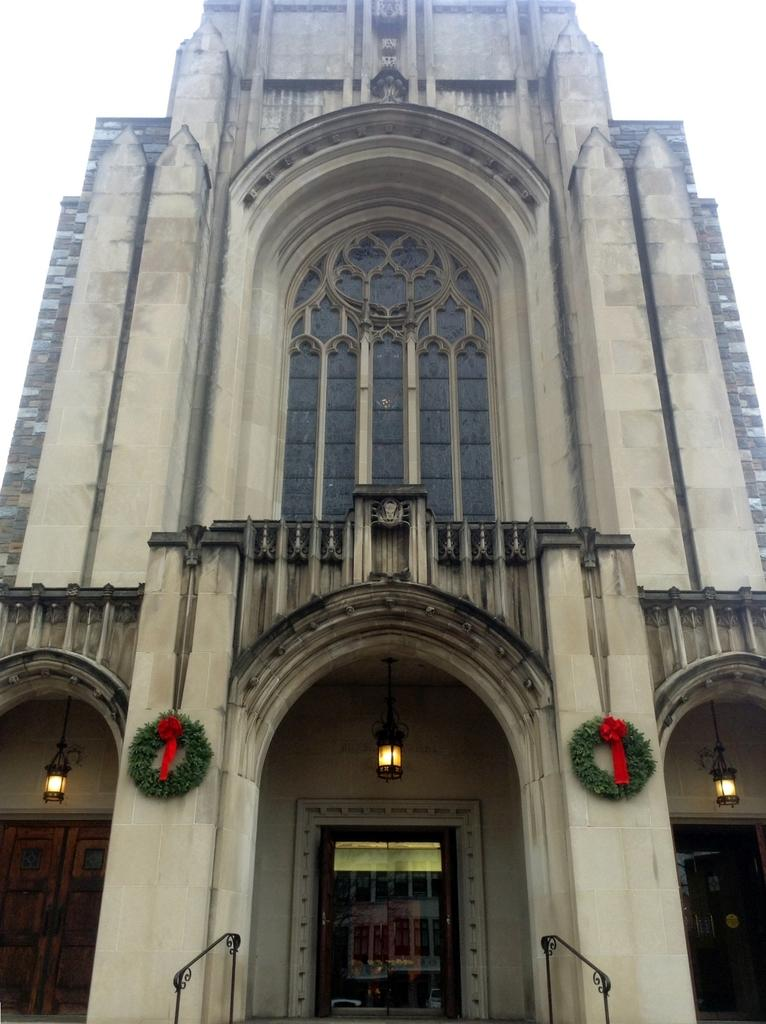What type of structure is present in the image? There is a building in the image. Can you describe any specific features of the building? Lights are visible in the building. How many pairs of shoes can be seen in the image? There are no shoes present in the image. What type of medical professional is depicted in the image? There is no doctor depicted in the image. How many brothers are visible in the image? There are no people, including brothers, present in the image. 